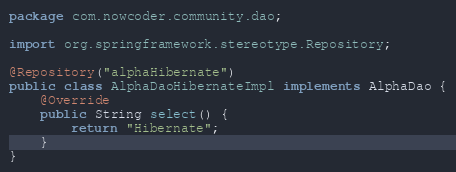Convert code to text. <code><loc_0><loc_0><loc_500><loc_500><_Java_>package com.nowcoder.community.dao;

import org.springframework.stereotype.Repository;

@Repository("alphaHibernate")
public class AlphaDaoHibernateImpl implements AlphaDao {
    @Override
    public String select() {
        return "Hibernate";
    }
}
</code> 